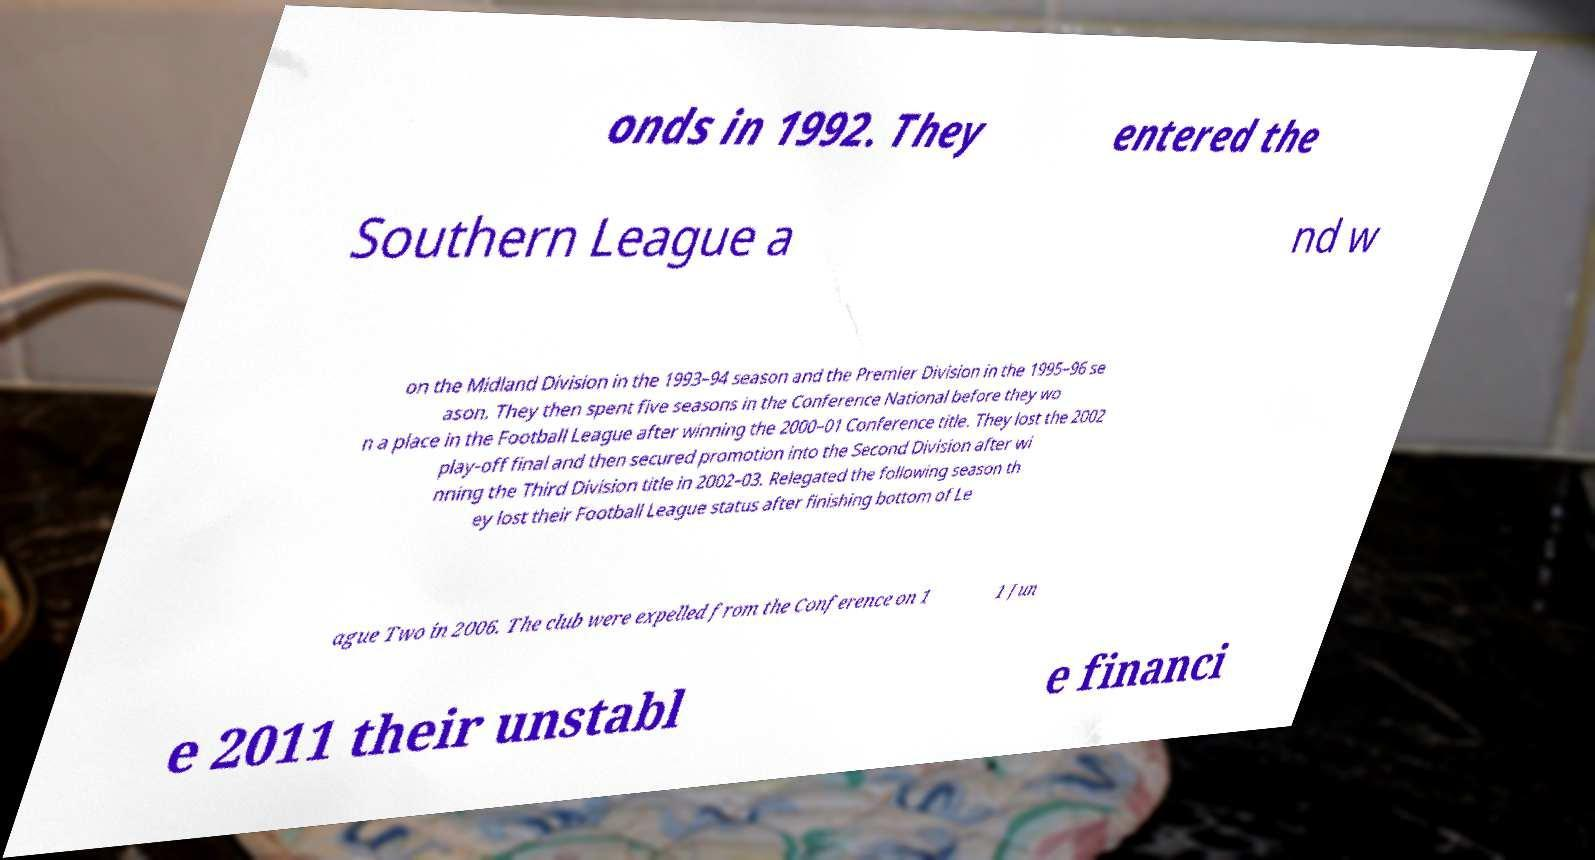Can you read and provide the text displayed in the image?This photo seems to have some interesting text. Can you extract and type it out for me? onds in 1992. They entered the Southern League a nd w on the Midland Division in the 1993–94 season and the Premier Division in the 1995–96 se ason. They then spent five seasons in the Conference National before they wo n a place in the Football League after winning the 2000–01 Conference title. They lost the 2002 play-off final and then secured promotion into the Second Division after wi nning the Third Division title in 2002–03. Relegated the following season th ey lost their Football League status after finishing bottom of Le ague Two in 2006. The club were expelled from the Conference on 1 1 Jun e 2011 their unstabl e financi 